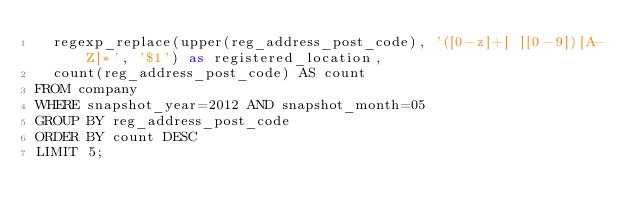Convert code to text. <code><loc_0><loc_0><loc_500><loc_500><_SQL_>  regexp_replace(upper(reg_address_post_code), '([0-z]+[ ][0-9])[A-Z]*', '$1') as registered_location,
  count(reg_address_post_code) AS count
FROM company
WHERE snapshot_year=2012 AND snapshot_month=05
GROUP BY reg_address_post_code
ORDER BY count DESC
LIMIT 5;


</code> 